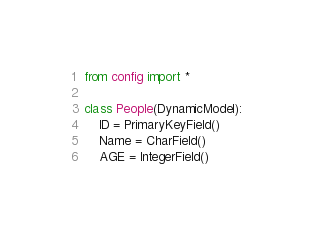Convert code to text. <code><loc_0><loc_0><loc_500><loc_500><_Python_>from config import *

class People(DynamicModel):
    ID = PrimaryKeyField()
    Name = CharField()
    AGE = IntegerField()
</code> 